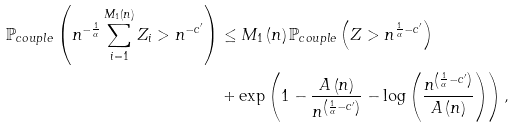Convert formula to latex. <formula><loc_0><loc_0><loc_500><loc_500>\mathbb { P } _ { c o u p l e } \left ( n ^ { - \frac { 1 } { \alpha } } \sum _ { i = 1 } ^ { M _ { 1 } \left ( n \right ) } Z _ { i } > n ^ { - c ^ { \prime } } \right ) & \leq M _ { 1 } \left ( n \right ) \mathbb { P } _ { c o u p l e } \left ( Z > n ^ { \frac { 1 } { \alpha } - c ^ { \prime } } \right ) \\ & + \exp \left ( 1 - \frac { A \left ( n \right ) } { n ^ { \left ( \frac { 1 } { \alpha } - c ^ { \prime } \right ) } } - \log \left ( \frac { n ^ { \left ( \frac { 1 } { \alpha } - c ^ { \prime } \right ) } } { A \left ( n \right ) } \right ) \right ) ,</formula> 